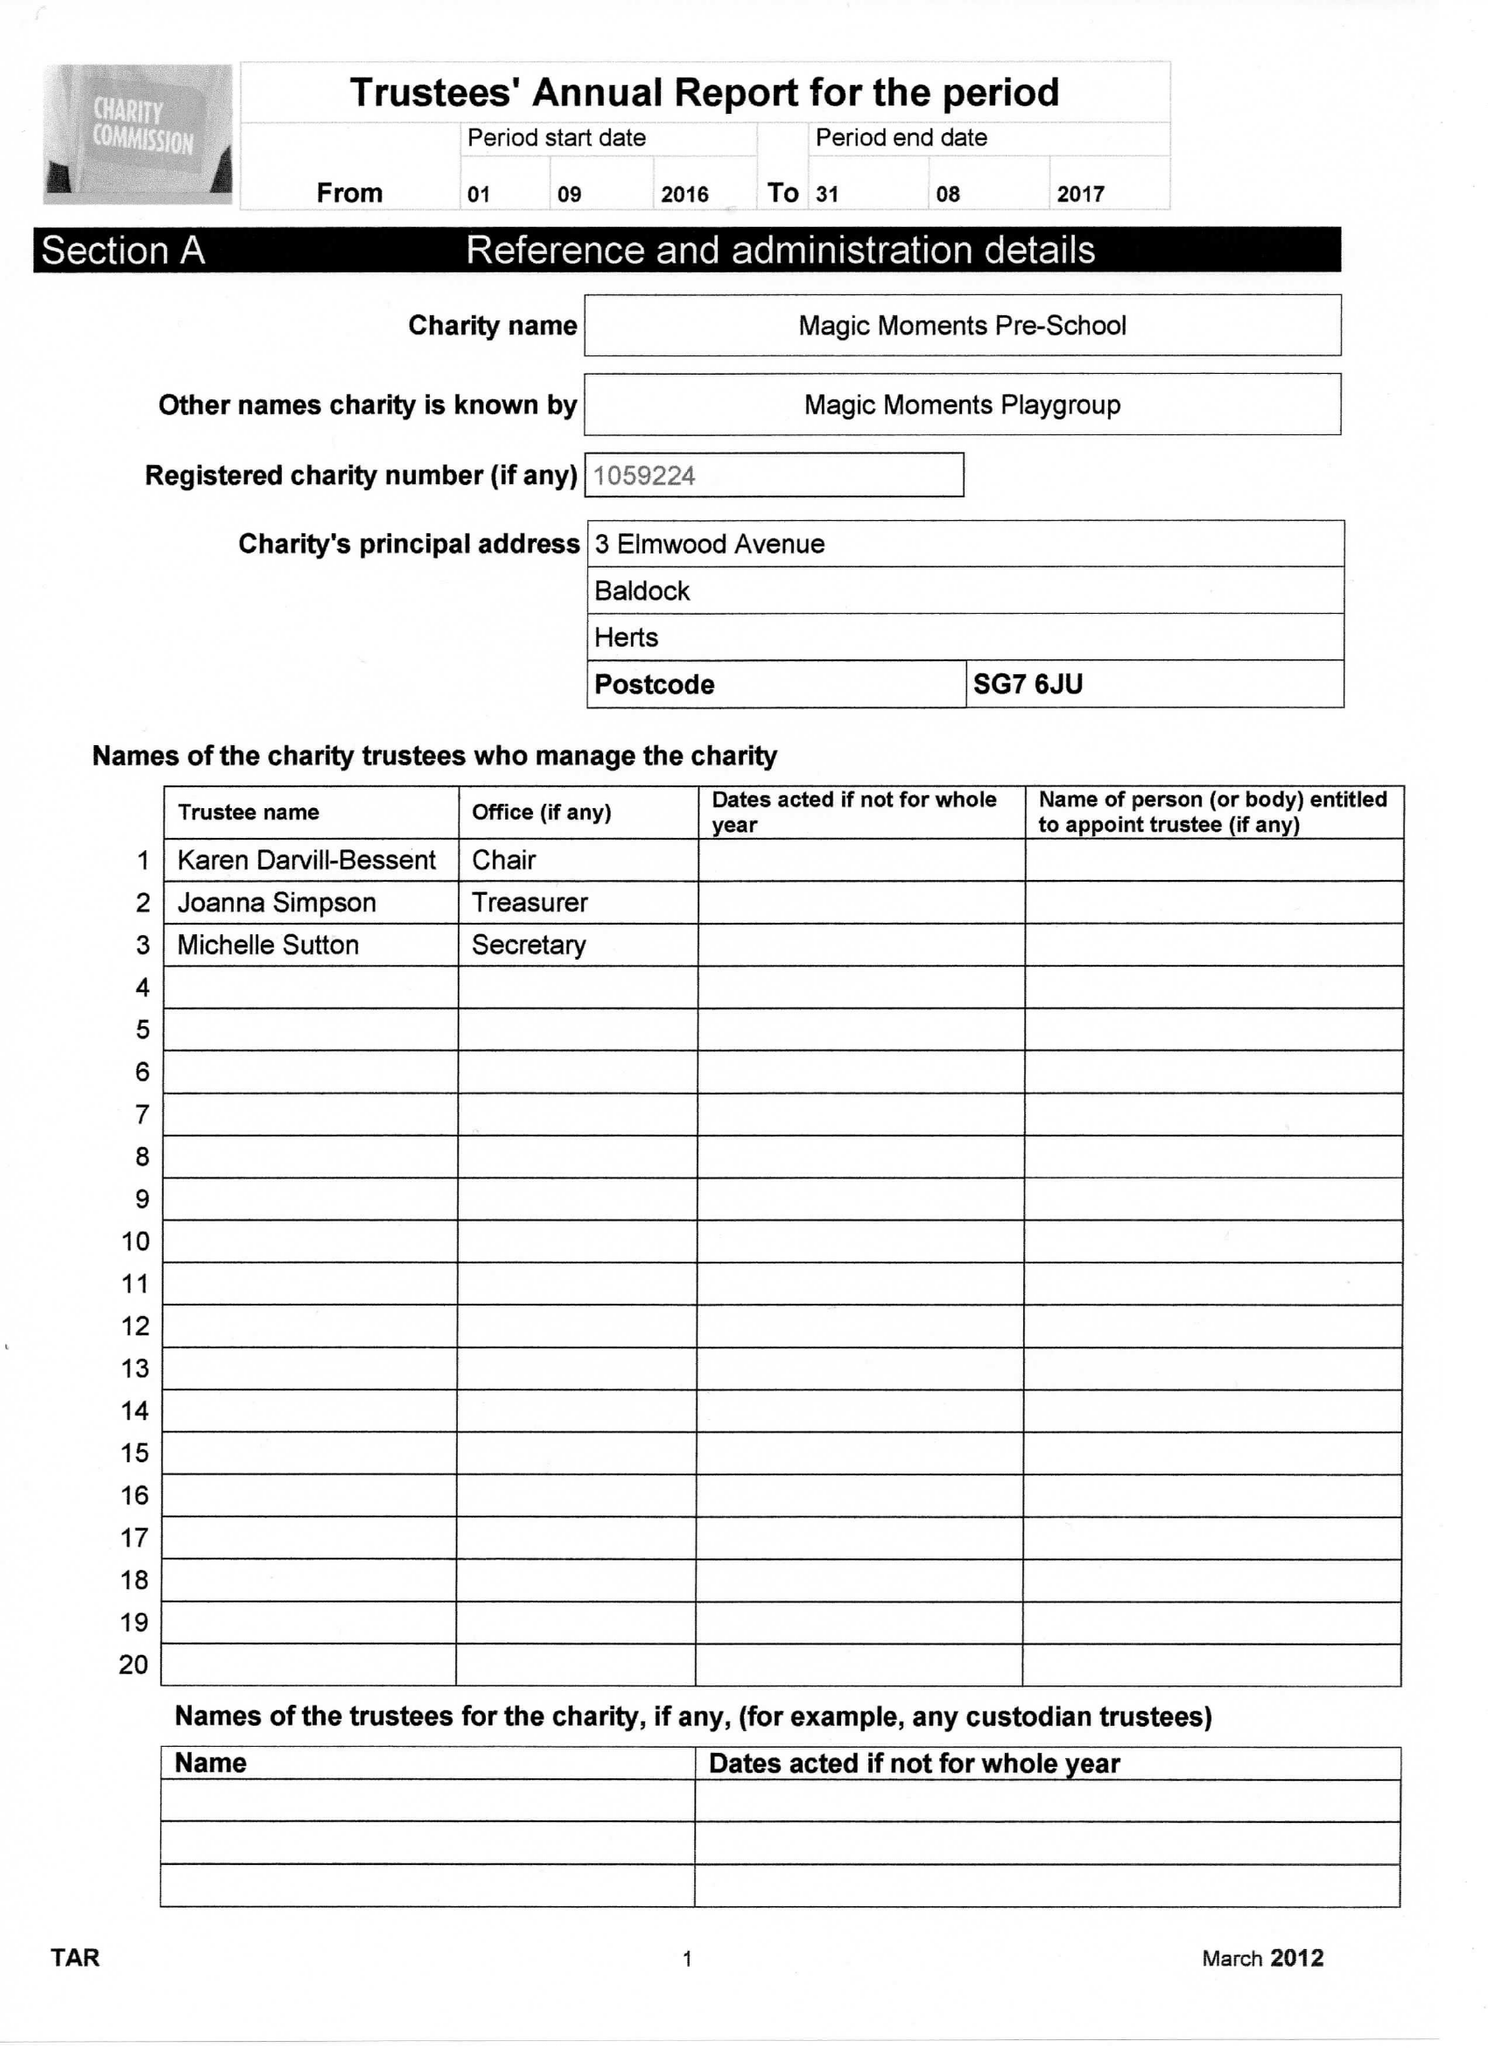What is the value for the income_annually_in_british_pounds?
Answer the question using a single word or phrase. 126745.00 